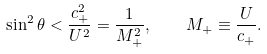Convert formula to latex. <formula><loc_0><loc_0><loc_500><loc_500>\sin ^ { 2 } \theta < \frac { c _ { + } ^ { 2 } } { U ^ { 2 } } = \frac { 1 } { M _ { + } ^ { 2 } } , \quad M _ { + } \equiv \frac { U } { c _ { + } } .</formula> 